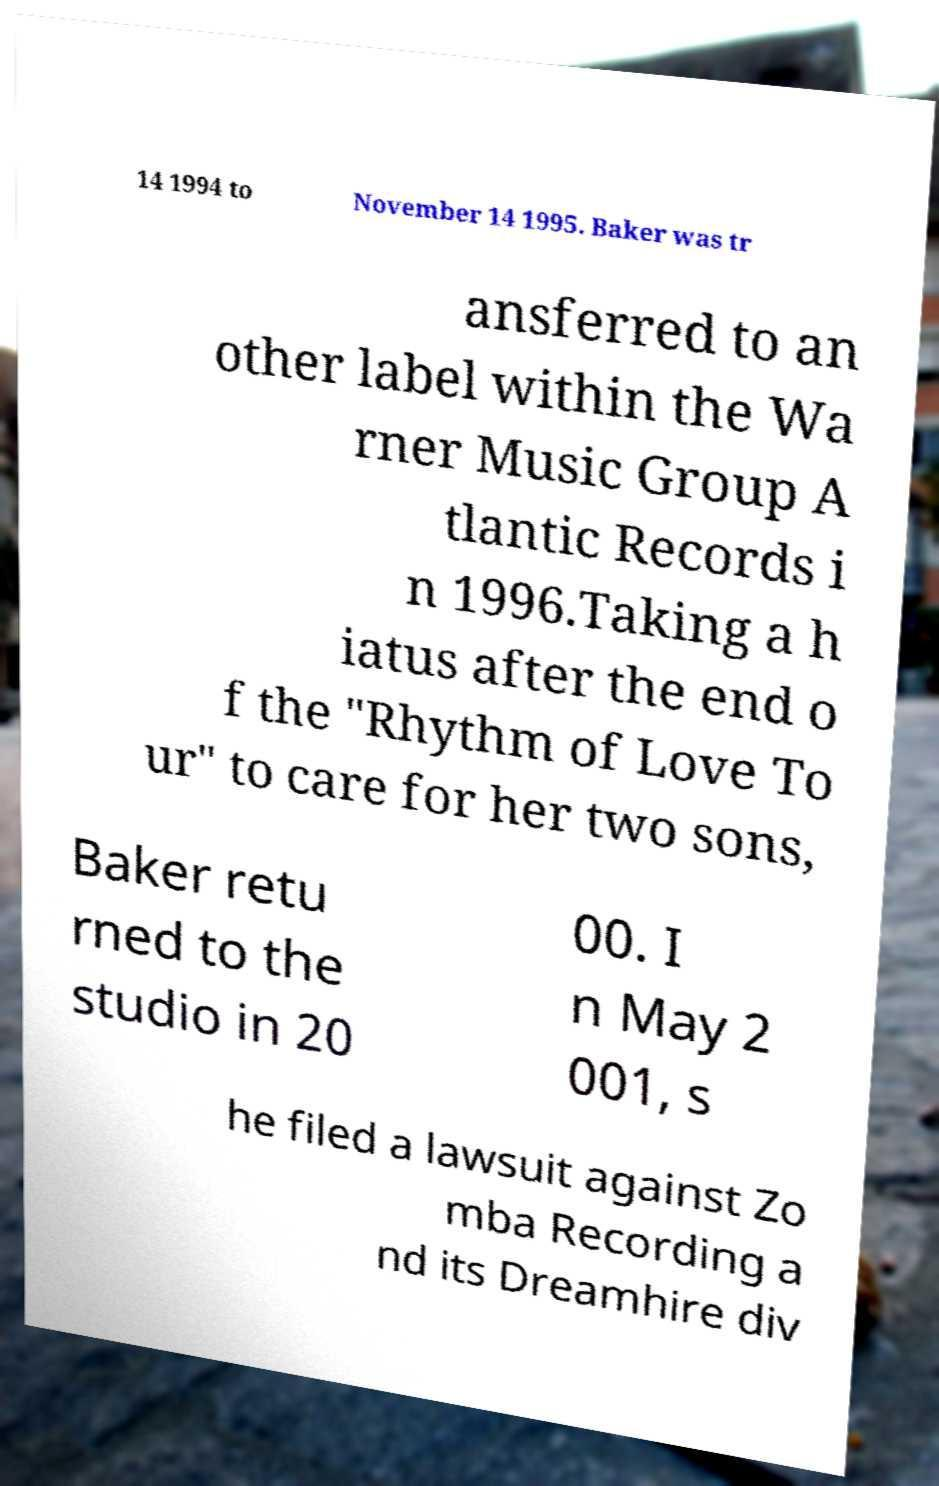For documentation purposes, I need the text within this image transcribed. Could you provide that? 14 1994 to November 14 1995. Baker was tr ansferred to an other label within the Wa rner Music Group A tlantic Records i n 1996.Taking a h iatus after the end o f the "Rhythm of Love To ur" to care for her two sons, Baker retu rned to the studio in 20 00. I n May 2 001, s he filed a lawsuit against Zo mba Recording a nd its Dreamhire div 